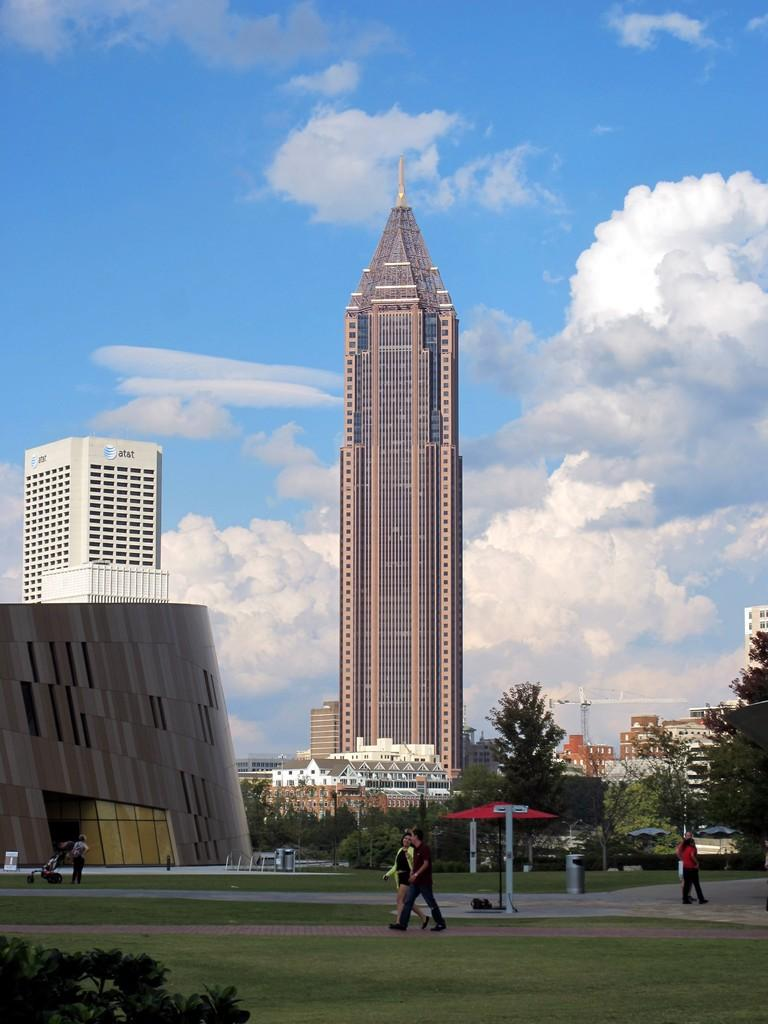What are the people in the image doing? The people in the image are walking on the ground. What type of vegetation can be seen in the image? Trees are present in the image. What type of structures are visible in the image? Buildings are visible in the image. What object is used for waste disposal in the image? There is a bin in the image. What type of ground surface is present in the image? Grass is present in the image. What can be seen in the background of the image? The sky with clouds is visible in the background of the image. What type of circle or pie can be seen in the image? There is no circle or pie present in the image. What type of engine is visible in the image? There is no engine present in the image. 